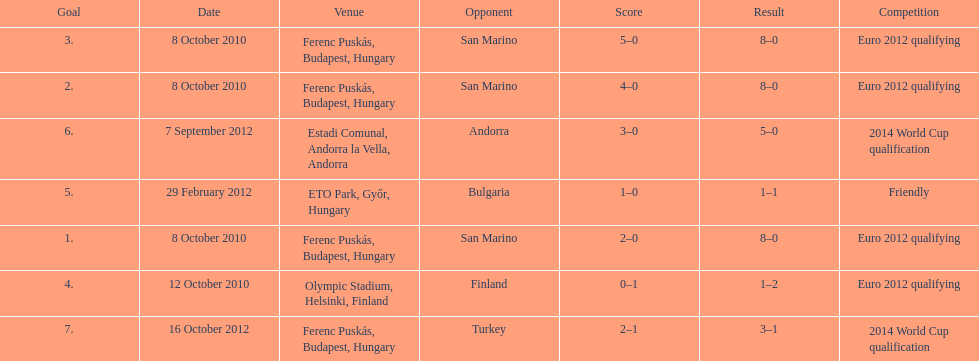Szalai scored all but one of his international goals in either euro 2012 qualifying or what other level of play? 2014 World Cup qualification. 